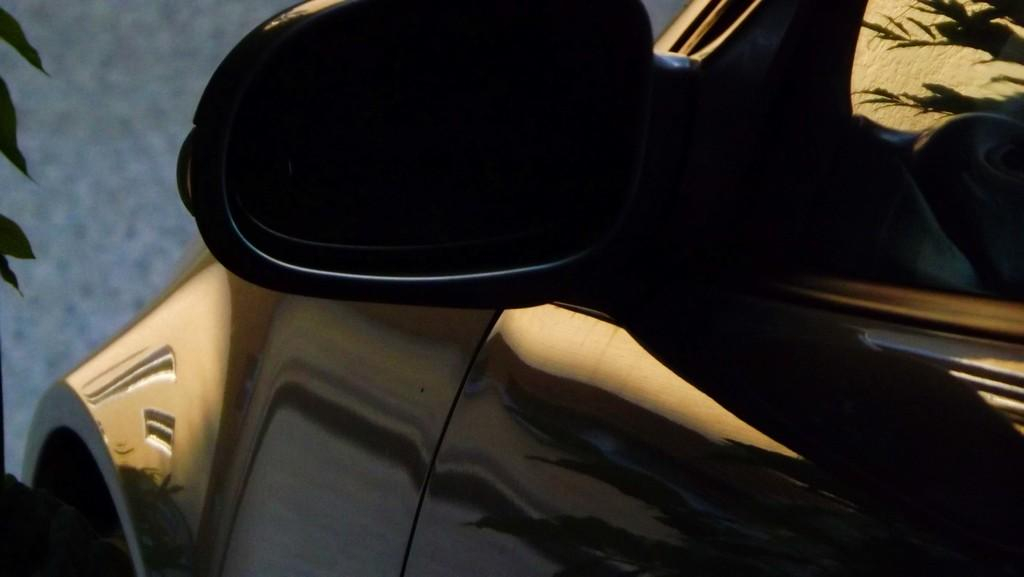What is the focus of the image? The image is zoomed in on a specific object. What object is in the foreground of the image? There is an object that appears to be a car in the foreground. What can be seen in the background of the image? Leaves and the ground are visible in the background. What type of celery is being used to reduce friction on the car's tires in the image? There is no celery present in the image, nor is there any indication of friction or the need to reduce it. 